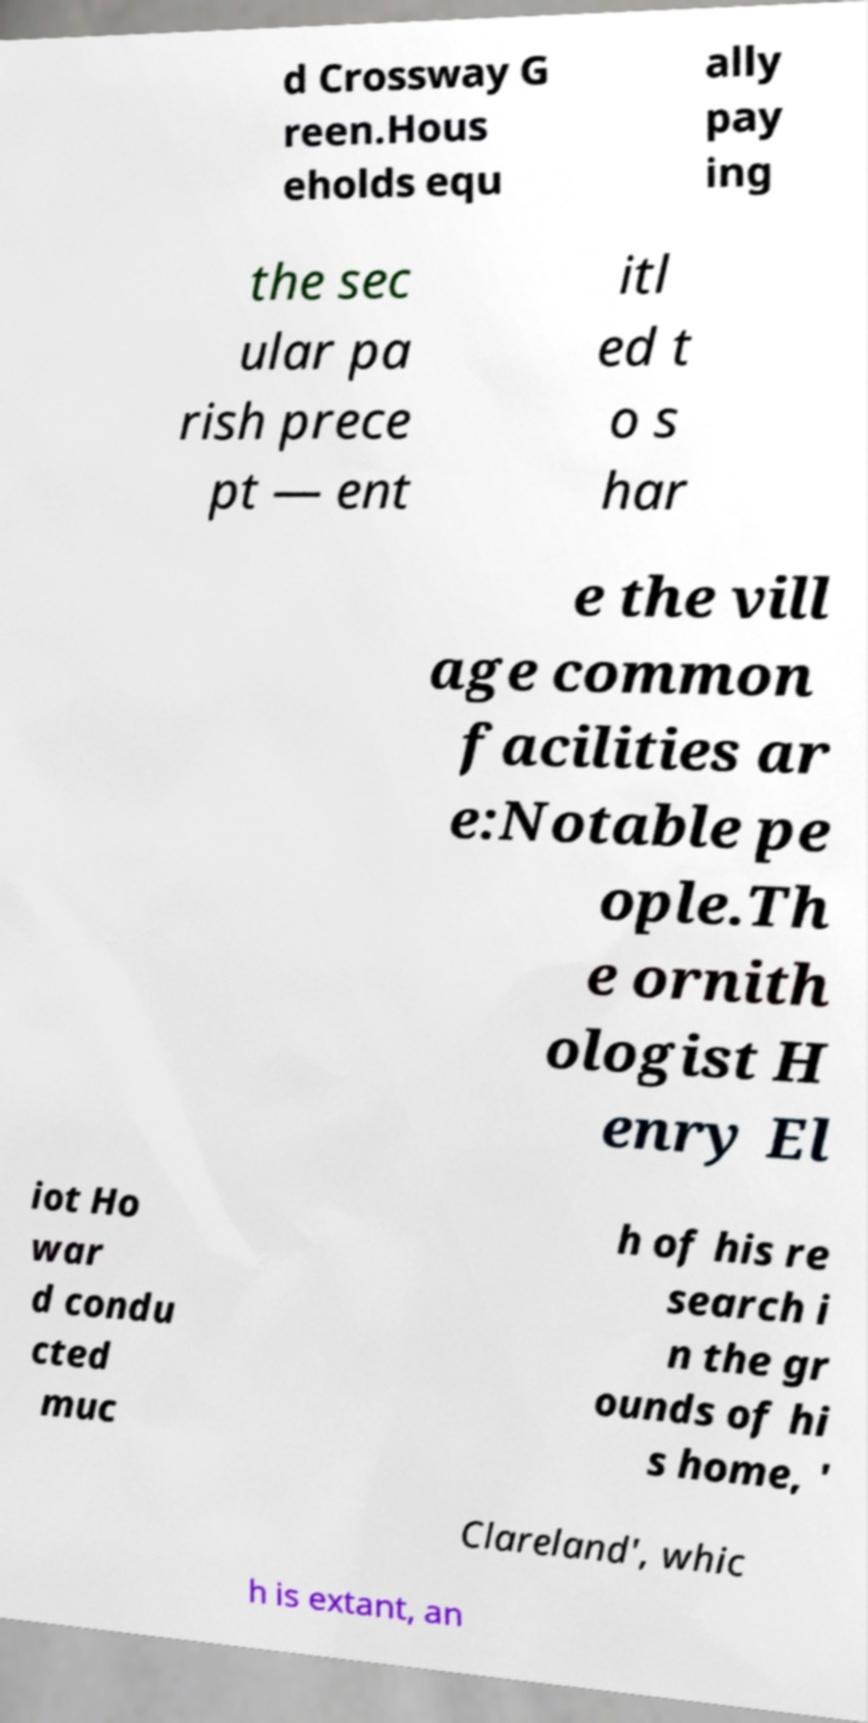For documentation purposes, I need the text within this image transcribed. Could you provide that? d Crossway G reen.Hous eholds equ ally pay ing the sec ular pa rish prece pt — ent itl ed t o s har e the vill age common facilities ar e:Notable pe ople.Th e ornith ologist H enry El iot Ho war d condu cted muc h of his re search i n the gr ounds of hi s home, ' Clareland', whic h is extant, an 